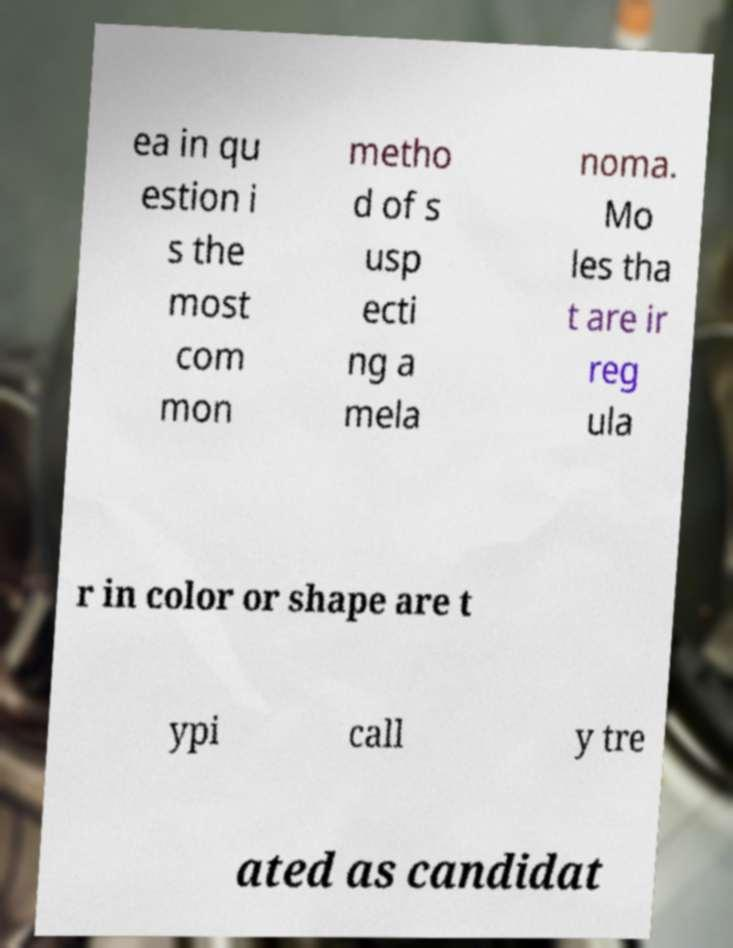Could you assist in decoding the text presented in this image and type it out clearly? ea in qu estion i s the most com mon metho d of s usp ecti ng a mela noma. Mo les tha t are ir reg ula r in color or shape are t ypi call y tre ated as candidat 